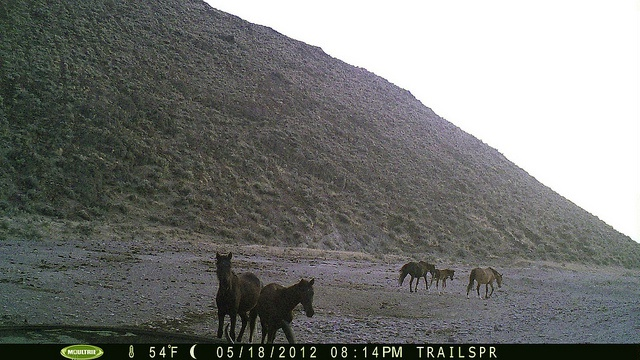Describe the objects in this image and their specific colors. I can see horse in darkgreen, black, and gray tones, horse in darkgreen, black, and gray tones, horse in darkgreen, gray, and black tones, horse in darkgreen, black, and gray tones, and horse in darkgreen, black, and gray tones in this image. 